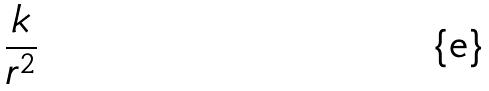<formula> <loc_0><loc_0><loc_500><loc_500>\frac { k } { r ^ { 2 } }</formula> 